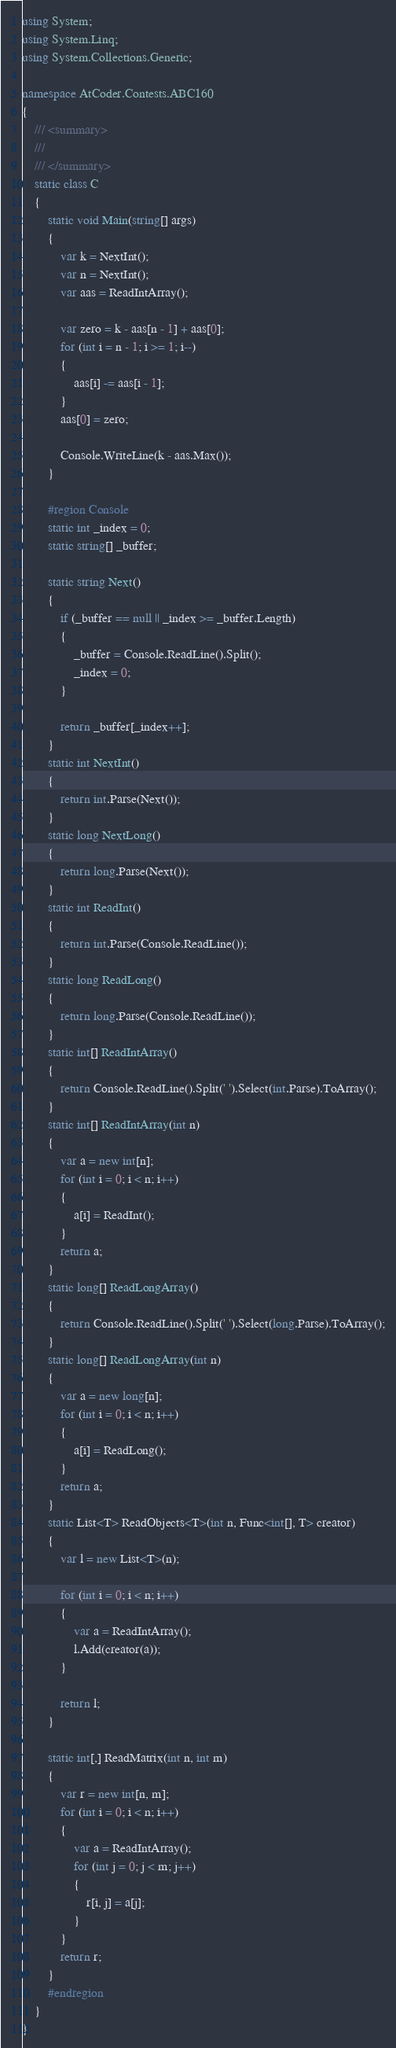<code> <loc_0><loc_0><loc_500><loc_500><_C#_>using System;
using System.Linq;
using System.Collections.Generic;

namespace AtCoder.Contests.ABC160
{
    /// <summary>
    /// 
    /// </summary>
    static class C
    {
        static void Main(string[] args)
        {
            var k = NextInt();
            var n = NextInt();
            var aas = ReadIntArray();

            var zero = k - aas[n - 1] + aas[0];
            for (int i = n - 1; i >= 1; i--)
            {
                aas[i] -= aas[i - 1];
            }
            aas[0] = zero;

            Console.WriteLine(k - aas.Max());
        }

        #region Console
        static int _index = 0;
        static string[] _buffer;

        static string Next()
        {
            if (_buffer == null || _index >= _buffer.Length)
            {
                _buffer = Console.ReadLine().Split();
                _index = 0;
            }

            return _buffer[_index++];
        }
        static int NextInt()
        {
            return int.Parse(Next());
        }
        static long NextLong()
        {
            return long.Parse(Next());
        }
        static int ReadInt()
        {
            return int.Parse(Console.ReadLine());
        }
        static long ReadLong()
        {
            return long.Parse(Console.ReadLine());
        }
        static int[] ReadIntArray()
        {
            return Console.ReadLine().Split(' ').Select(int.Parse).ToArray();
        }
        static int[] ReadIntArray(int n)
        {
            var a = new int[n];
            for (int i = 0; i < n; i++)
            {
                a[i] = ReadInt();
            }
            return a;
        }
        static long[] ReadLongArray()
        {
            return Console.ReadLine().Split(' ').Select(long.Parse).ToArray();
        }
        static long[] ReadLongArray(int n)
        {
            var a = new long[n];
            for (int i = 0; i < n; i++)
            {
                a[i] = ReadLong();
            }
            return a;
        }
        static List<T> ReadObjects<T>(int n, Func<int[], T> creator)
        {
            var l = new List<T>(n);

            for (int i = 0; i < n; i++)
            {
                var a = ReadIntArray();
                l.Add(creator(a));
            }

            return l;
        }

        static int[,] ReadMatrix(int n, int m)
        {
            var r = new int[n, m];
            for (int i = 0; i < n; i++)
            {
                var a = ReadIntArray();
                for (int j = 0; j < m; j++)
                {
                    r[i, j] = a[j];
                }
            }
            return r;
        }
        #endregion
    }
}
</code> 